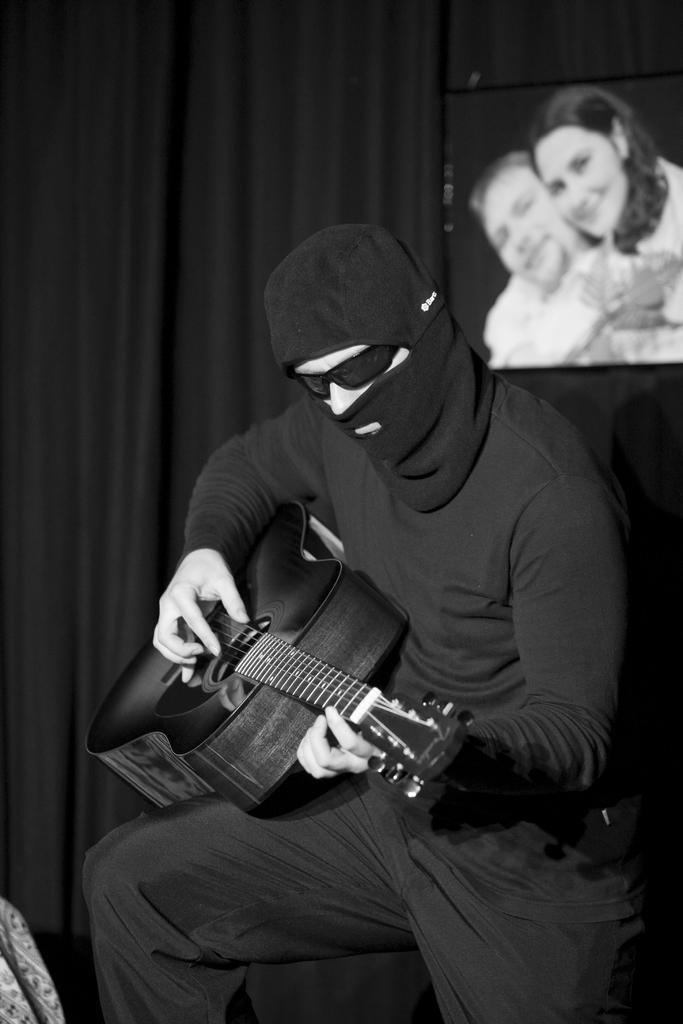Could you give a brief overview of what you see in this image? In this picture a man is playing guitar, and we can see a photo frame and curtains. 